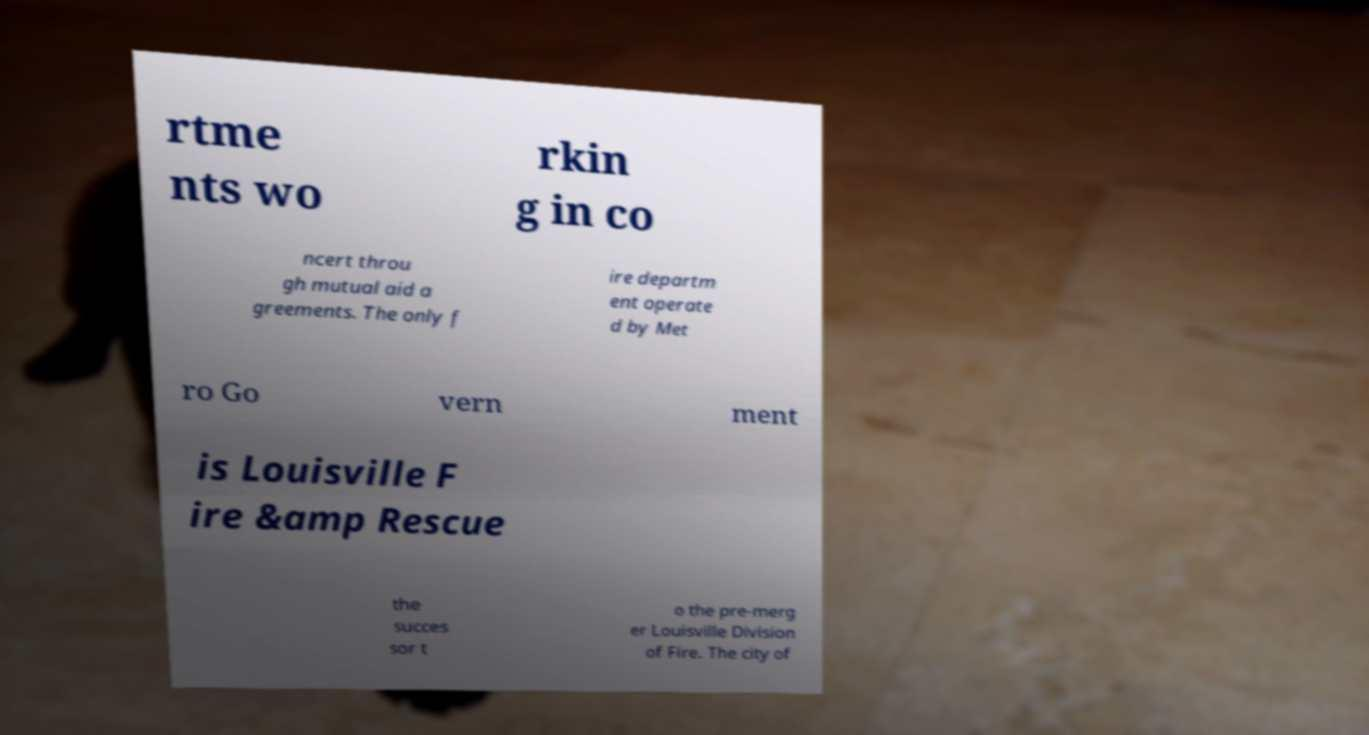Please read and relay the text visible in this image. What does it say? rtme nts wo rkin g in co ncert throu gh mutual aid a greements. The only f ire departm ent operate d by Met ro Go vern ment is Louisville F ire &amp Rescue the succes sor t o the pre-merg er Louisville Division of Fire. The city of 